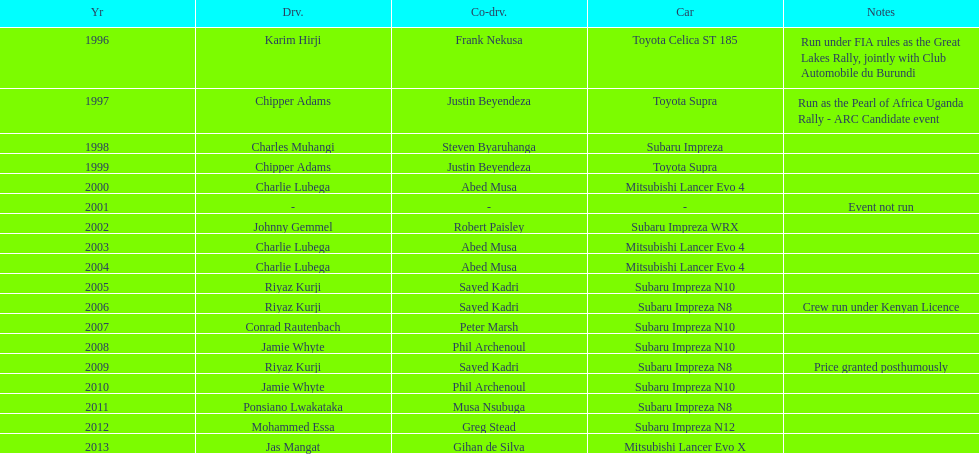What is the number of instances when charlie lubega served as a driver? 3. 